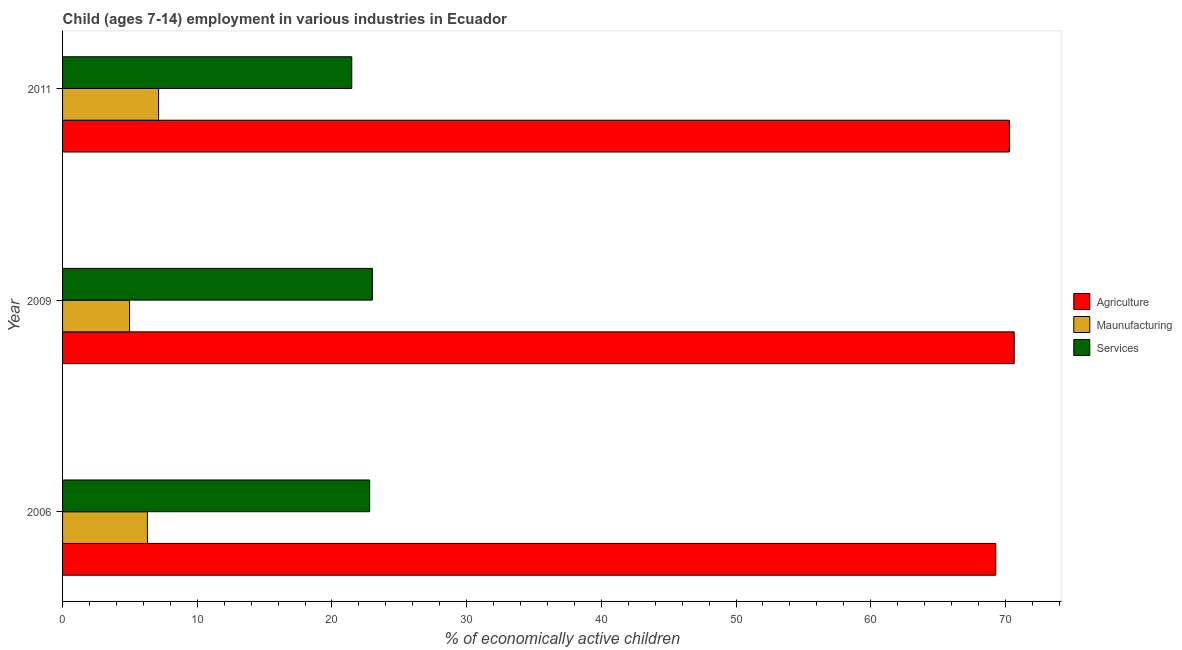How many different coloured bars are there?
Provide a succinct answer. 3. How many groups of bars are there?
Provide a succinct answer. 3. Are the number of bars per tick equal to the number of legend labels?
Keep it short and to the point. Yes. Are the number of bars on each tick of the Y-axis equal?
Give a very brief answer. Yes. How many bars are there on the 3rd tick from the top?
Your answer should be very brief. 3. In how many cases, is the number of bars for a given year not equal to the number of legend labels?
Ensure brevity in your answer.  0. What is the percentage of economically active children in agriculture in 2011?
Offer a terse response. 70.29. Across all years, what is the maximum percentage of economically active children in agriculture?
Ensure brevity in your answer.  70.65. Across all years, what is the minimum percentage of economically active children in manufacturing?
Offer a terse response. 4.97. In which year was the percentage of economically active children in agriculture minimum?
Your response must be concise. 2006. What is the total percentage of economically active children in agriculture in the graph?
Your answer should be compact. 210.22. What is the difference between the percentage of economically active children in services in 2006 and the percentage of economically active children in agriculture in 2009?
Offer a terse response. -47.85. What is the average percentage of economically active children in manufacturing per year?
Make the answer very short. 6.13. In the year 2009, what is the difference between the percentage of economically active children in agriculture and percentage of economically active children in services?
Provide a succinct answer. 47.65. What is the ratio of the percentage of economically active children in manufacturing in 2006 to that in 2011?
Offer a very short reply. 0.88. Is the percentage of economically active children in manufacturing in 2006 less than that in 2011?
Your answer should be compact. Yes. Is the difference between the percentage of economically active children in manufacturing in 2009 and 2011 greater than the difference between the percentage of economically active children in services in 2009 and 2011?
Your answer should be very brief. No. What is the difference between the highest and the second highest percentage of economically active children in agriculture?
Your response must be concise. 0.36. What is the difference between the highest and the lowest percentage of economically active children in agriculture?
Your answer should be compact. 1.37. Is the sum of the percentage of economically active children in services in 2006 and 2011 greater than the maximum percentage of economically active children in agriculture across all years?
Ensure brevity in your answer.  No. What does the 2nd bar from the top in 2011 represents?
Your answer should be very brief. Maunufacturing. What does the 2nd bar from the bottom in 2009 represents?
Provide a succinct answer. Maunufacturing. Are all the bars in the graph horizontal?
Ensure brevity in your answer.  Yes. How many years are there in the graph?
Your answer should be very brief. 3. What is the difference between two consecutive major ticks on the X-axis?
Give a very brief answer. 10. Does the graph contain any zero values?
Keep it short and to the point. No. Does the graph contain grids?
Provide a short and direct response. No. Where does the legend appear in the graph?
Provide a succinct answer. Center right. How are the legend labels stacked?
Provide a succinct answer. Vertical. What is the title of the graph?
Your response must be concise. Child (ages 7-14) employment in various industries in Ecuador. What is the label or title of the X-axis?
Make the answer very short. % of economically active children. What is the % of economically active children in Agriculture in 2006?
Provide a short and direct response. 69.28. What is the % of economically active children in Maunufacturing in 2006?
Offer a terse response. 6.3. What is the % of economically active children of Services in 2006?
Offer a very short reply. 22.8. What is the % of economically active children in Agriculture in 2009?
Your answer should be compact. 70.65. What is the % of economically active children in Maunufacturing in 2009?
Your response must be concise. 4.97. What is the % of economically active children in Agriculture in 2011?
Your answer should be compact. 70.29. What is the % of economically active children of Maunufacturing in 2011?
Offer a very short reply. 7.13. What is the % of economically active children in Services in 2011?
Provide a short and direct response. 21.47. Across all years, what is the maximum % of economically active children of Agriculture?
Ensure brevity in your answer.  70.65. Across all years, what is the maximum % of economically active children in Maunufacturing?
Keep it short and to the point. 7.13. Across all years, what is the maximum % of economically active children in Services?
Give a very brief answer. 23. Across all years, what is the minimum % of economically active children in Agriculture?
Offer a very short reply. 69.28. Across all years, what is the minimum % of economically active children of Maunufacturing?
Your response must be concise. 4.97. Across all years, what is the minimum % of economically active children of Services?
Your answer should be compact. 21.47. What is the total % of economically active children in Agriculture in the graph?
Provide a short and direct response. 210.22. What is the total % of economically active children of Services in the graph?
Keep it short and to the point. 67.27. What is the difference between the % of economically active children of Agriculture in 2006 and that in 2009?
Your answer should be compact. -1.37. What is the difference between the % of economically active children in Maunufacturing in 2006 and that in 2009?
Provide a succinct answer. 1.33. What is the difference between the % of economically active children of Agriculture in 2006 and that in 2011?
Offer a terse response. -1.01. What is the difference between the % of economically active children of Maunufacturing in 2006 and that in 2011?
Your answer should be very brief. -0.83. What is the difference between the % of economically active children of Services in 2006 and that in 2011?
Offer a terse response. 1.33. What is the difference between the % of economically active children of Agriculture in 2009 and that in 2011?
Make the answer very short. 0.36. What is the difference between the % of economically active children of Maunufacturing in 2009 and that in 2011?
Your answer should be compact. -2.16. What is the difference between the % of economically active children in Services in 2009 and that in 2011?
Provide a succinct answer. 1.53. What is the difference between the % of economically active children in Agriculture in 2006 and the % of economically active children in Maunufacturing in 2009?
Provide a short and direct response. 64.31. What is the difference between the % of economically active children of Agriculture in 2006 and the % of economically active children of Services in 2009?
Offer a very short reply. 46.28. What is the difference between the % of economically active children in Maunufacturing in 2006 and the % of economically active children in Services in 2009?
Offer a terse response. -16.7. What is the difference between the % of economically active children in Agriculture in 2006 and the % of economically active children in Maunufacturing in 2011?
Ensure brevity in your answer.  62.15. What is the difference between the % of economically active children of Agriculture in 2006 and the % of economically active children of Services in 2011?
Offer a terse response. 47.81. What is the difference between the % of economically active children of Maunufacturing in 2006 and the % of economically active children of Services in 2011?
Your answer should be very brief. -15.17. What is the difference between the % of economically active children of Agriculture in 2009 and the % of economically active children of Maunufacturing in 2011?
Provide a short and direct response. 63.52. What is the difference between the % of economically active children in Agriculture in 2009 and the % of economically active children in Services in 2011?
Offer a terse response. 49.18. What is the difference between the % of economically active children of Maunufacturing in 2009 and the % of economically active children of Services in 2011?
Your response must be concise. -16.5. What is the average % of economically active children in Agriculture per year?
Provide a succinct answer. 70.07. What is the average % of economically active children of Maunufacturing per year?
Offer a very short reply. 6.13. What is the average % of economically active children of Services per year?
Make the answer very short. 22.42. In the year 2006, what is the difference between the % of economically active children in Agriculture and % of economically active children in Maunufacturing?
Give a very brief answer. 62.98. In the year 2006, what is the difference between the % of economically active children of Agriculture and % of economically active children of Services?
Provide a short and direct response. 46.48. In the year 2006, what is the difference between the % of economically active children in Maunufacturing and % of economically active children in Services?
Your answer should be very brief. -16.5. In the year 2009, what is the difference between the % of economically active children of Agriculture and % of economically active children of Maunufacturing?
Ensure brevity in your answer.  65.68. In the year 2009, what is the difference between the % of economically active children of Agriculture and % of economically active children of Services?
Ensure brevity in your answer.  47.65. In the year 2009, what is the difference between the % of economically active children of Maunufacturing and % of economically active children of Services?
Your response must be concise. -18.03. In the year 2011, what is the difference between the % of economically active children in Agriculture and % of economically active children in Maunufacturing?
Your answer should be compact. 63.16. In the year 2011, what is the difference between the % of economically active children in Agriculture and % of economically active children in Services?
Provide a succinct answer. 48.82. In the year 2011, what is the difference between the % of economically active children in Maunufacturing and % of economically active children in Services?
Ensure brevity in your answer.  -14.34. What is the ratio of the % of economically active children in Agriculture in 2006 to that in 2009?
Your answer should be compact. 0.98. What is the ratio of the % of economically active children of Maunufacturing in 2006 to that in 2009?
Give a very brief answer. 1.27. What is the ratio of the % of economically active children of Agriculture in 2006 to that in 2011?
Your response must be concise. 0.99. What is the ratio of the % of economically active children of Maunufacturing in 2006 to that in 2011?
Provide a succinct answer. 0.88. What is the ratio of the % of economically active children in Services in 2006 to that in 2011?
Offer a terse response. 1.06. What is the ratio of the % of economically active children in Agriculture in 2009 to that in 2011?
Make the answer very short. 1.01. What is the ratio of the % of economically active children in Maunufacturing in 2009 to that in 2011?
Your answer should be compact. 0.7. What is the ratio of the % of economically active children in Services in 2009 to that in 2011?
Offer a very short reply. 1.07. What is the difference between the highest and the second highest % of economically active children in Agriculture?
Make the answer very short. 0.36. What is the difference between the highest and the second highest % of economically active children of Maunufacturing?
Your response must be concise. 0.83. What is the difference between the highest and the lowest % of economically active children of Agriculture?
Provide a succinct answer. 1.37. What is the difference between the highest and the lowest % of economically active children of Maunufacturing?
Ensure brevity in your answer.  2.16. What is the difference between the highest and the lowest % of economically active children in Services?
Your response must be concise. 1.53. 